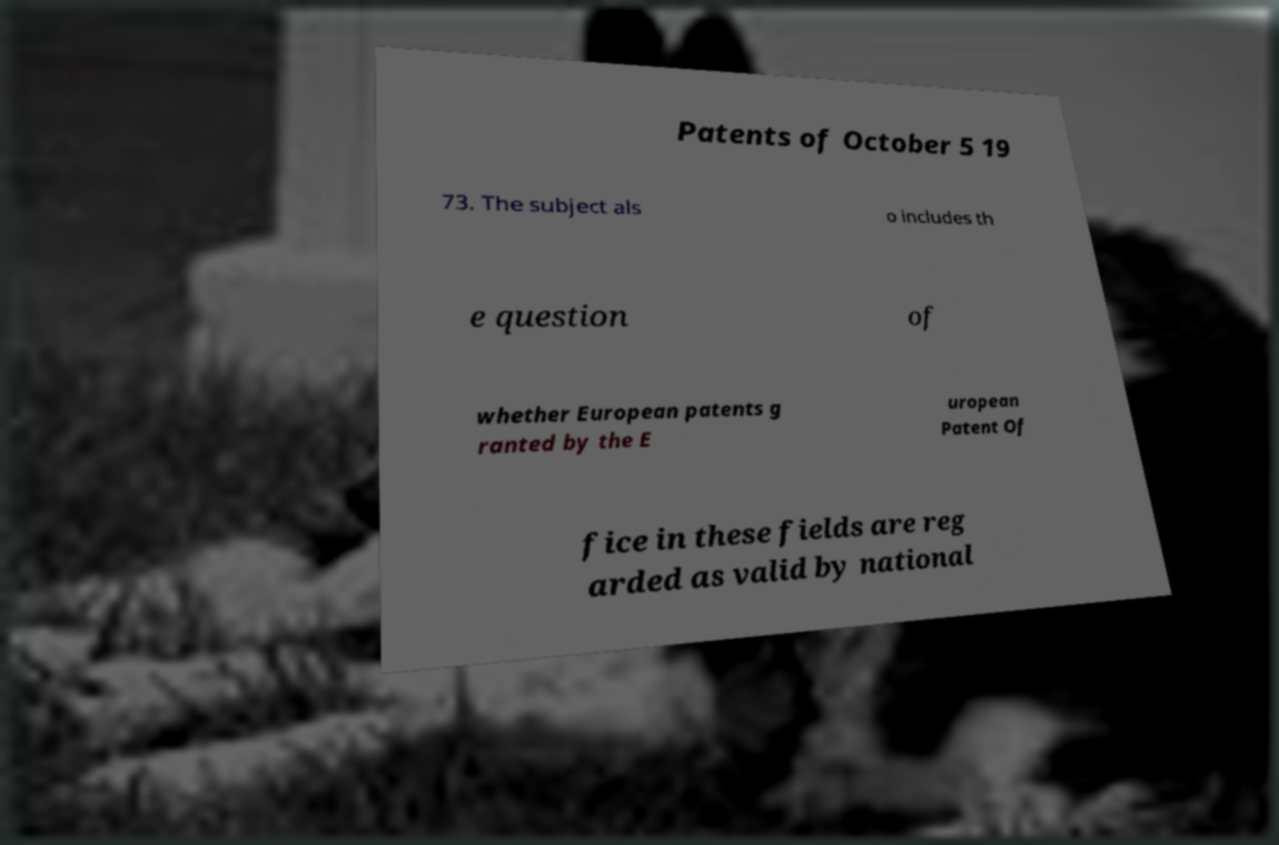For documentation purposes, I need the text within this image transcribed. Could you provide that? Patents of October 5 19 73. The subject als o includes th e question of whether European patents g ranted by the E uropean Patent Of fice in these fields are reg arded as valid by national 